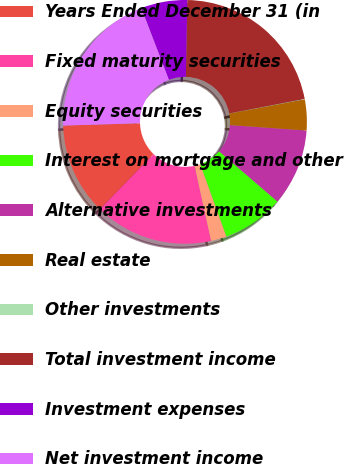Convert chart to OTSL. <chart><loc_0><loc_0><loc_500><loc_500><pie_chart><fcel>Years Ended December 31 (in<fcel>Fixed maturity securities<fcel>Equity securities<fcel>Interest on mortgage and other<fcel>Alternative investments<fcel>Real estate<fcel>Other investments<fcel>Total investment income<fcel>Investment expenses<fcel>Net investment income<nl><fcel>12.22%<fcel>15.74%<fcel>2.08%<fcel>8.16%<fcel>10.19%<fcel>4.1%<fcel>0.05%<fcel>21.68%<fcel>6.13%<fcel>19.65%<nl></chart> 